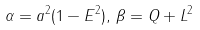Convert formula to latex. <formula><loc_0><loc_0><loc_500><loc_500>\alpha = a ^ { 2 } ( 1 - E ^ { 2 } ) , \, \beta = Q + L ^ { 2 }</formula> 